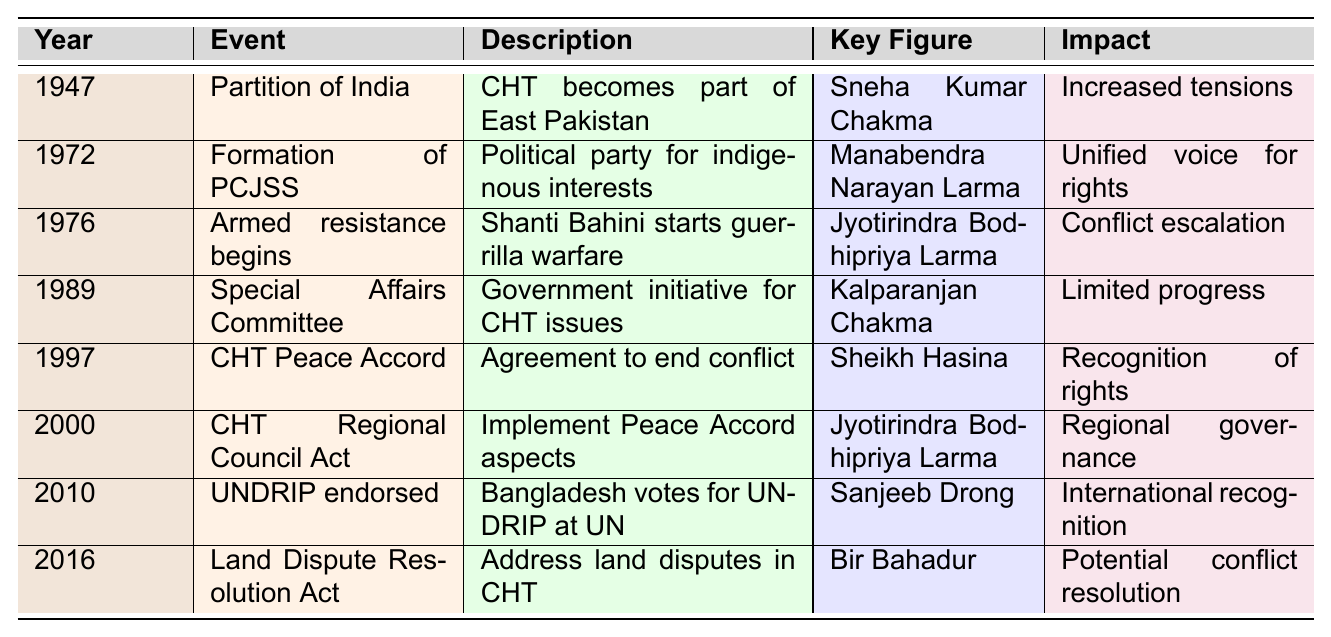What significant event occurred in 1947 concerning the Chittagong Hill Tracts? The table states that in 1947, the Partition of India took place, and the Chittagong Hill Tracts became part of East Pakistan.
Answer: Partition of India Who was the key figure in the formation of the PCJSS in 1972? According to the table, Manabendra Narayan Larma is listed as the key figure in the formation of the Parbatya Chattagram Jana Samhati Samiti (PCJSS) in 1972.
Answer: Manabendra Narayan Larma What impact did the CHT Peace Accord have in 1997? The CHT Peace Accord signed in 1997 is noted for its impact of formal recognition of indigenous rights and regional autonomy, according to the table.
Answer: Recognition of indigenous rights What was the trend in the nature of indigenous rights movements from 1947 to 2016? Reviewing the events listed over the years indicates a progression from increased tensions to armed resistance, then political representation, peacemaking efforts, and legal recognition, showing a trend towards formal acknowledgment of indigenous rights.
Answer: Progression towards formal recognition In which year did Bangladesh endorse the UN Declaration on the Rights of Indigenous Peoples? The data shows that Bangladesh voted in favor of the UN Declaration on the Rights of Indigenous Peoples in 2010.
Answer: 2010 How many events are listed before the signing of the CHT Peace Accord in 1997? Counting the events above 1997 in the table, there are four events (1947, 1972, 1976, and 1989) listed before the signing of the CHT Peace Accord.
Answer: Four Was the CHT Regional Council Act passed before or after the CHT Peace Accord? The table specifies that the CHT Regional Council Act was passed in 2000, which is after the CHT Peace Accord signed in 1997.
Answer: After What were the key issues addressed by the Special Affairs Committee formed in 1989? The table indicates that the Special Affairs Committee was a government initiative to address CHT issues, though it notes that the impact was limited progress in resolving conflicts.
Answer: Limited progress in resolving conflicts What was the role of Jyotirindra Bodhipriya Larma in the indigenous rights movements? According to the data, Jyotirindra Bodhipriya Larma played a significant role in two key events: leading the armed resistance movement starting in 1976 and being involved in the passage of the CHT Regional Council Act in 2000.
Answer: Leader in armed resistance and CHT Act Which event had a more significant impact: the signing of the CHT Peace Accord or the formation of PCJSS? The table describes the CHT Peace Accord as having formal recognition of indigenous rights and regional autonomy, which can be viewed as having a more significant, long-lasting impact compared to the formation of the PCJSS, which unified indigenous voices.
Answer: CHT Peace Accord What was the primary focus of the Land Dispute Resolution Commission Act in 2016? The table indicates that the focus of the CHT Land Dispute Resolution Commission (Amendment) Act in 2016 was to address land disputes within the CHT, aiming for potential resolution of longstanding conflicts.
Answer: Address land disputes Which event indicates the beginning of armed resistance and who was involved? The 1976 event titled 'Armed resistance begins' signifies the start of guerrilla warfare led by the Shanti Bahini, the armed wing of the PCJSS, with Jyotirindra Bodhipriya Larma being the key figure.
Answer: Armed resistance begins; Jyotirindra Bodhipriya Larma What difference can be observed between the impacts of the 1989 Special Affairs Committee and the 1997 CHT Peace Accord? The Special Affairs Committee formed in 1989 had a limited impact on resolving conflicts, whereas the CHT Peace Accord signed in 1997 had the significant impact of formally recognizing indigenous rights and granting regional autonomy.
Answer: Limited vs. significant impact 